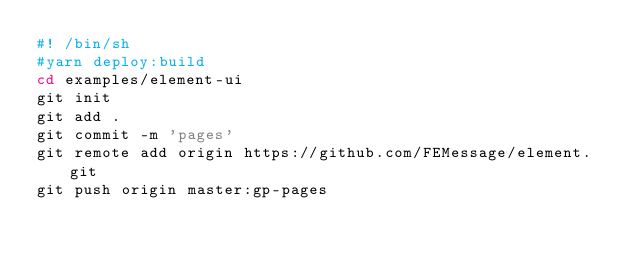<code> <loc_0><loc_0><loc_500><loc_500><_Bash_>#! /bin/sh
#yarn deploy:build
cd examples/element-ui
git init
git add .
git commit -m 'pages'
git remote add origin https://github.com/FEMessage/element.git
git push origin master:gp-pages
</code> 